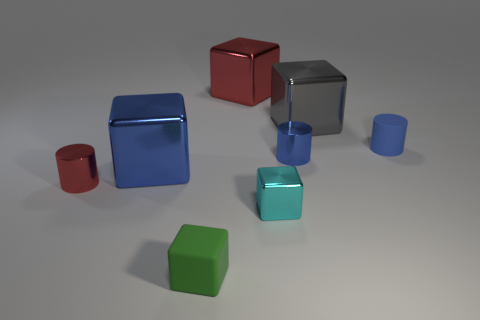Subtract all tiny metallic cylinders. How many cylinders are left? 1 Add 1 big gray things. How many objects exist? 9 Subtract 3 cylinders. How many cylinders are left? 0 Add 1 small blue metal things. How many small blue metal things are left? 2 Add 7 large brown rubber balls. How many large brown rubber balls exist? 7 Subtract all blue blocks. How many blocks are left? 4 Subtract 1 red cubes. How many objects are left? 7 Subtract all cubes. How many objects are left? 3 Subtract all green cylinders. Subtract all green blocks. How many cylinders are left? 3 Subtract all red cylinders. How many gray blocks are left? 1 